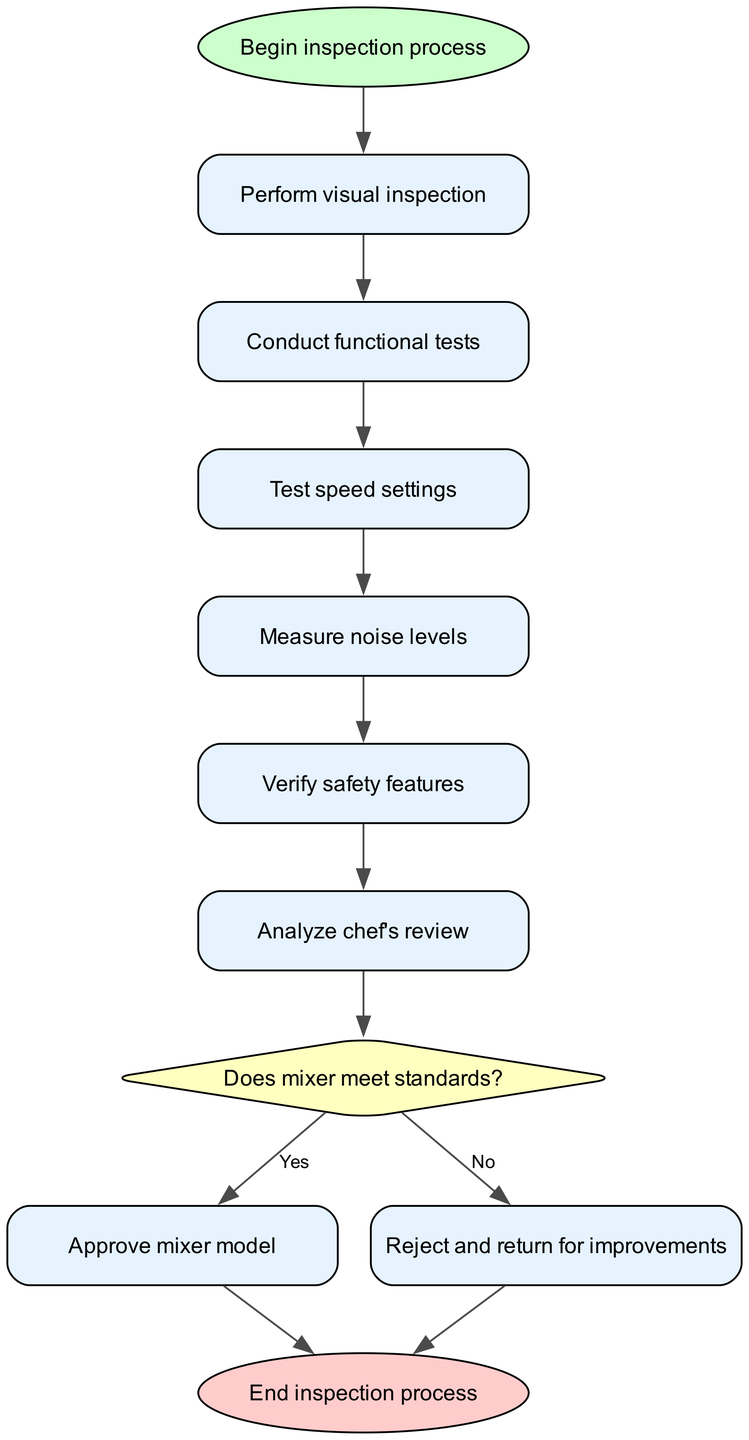What is the first step in the inspection process? The diagram shows that the first node is labeled "Begin inspection process," indicating it is the starting point of the flowchart.
Answer: Begin inspection process How many functional tests are conducted after visual inspection? From the diagram, the flow goes from "Perform visual inspection" to "Conduct functional tests," which indicates that one functional test is conducted after the visual inspection.
Answer: One What is the last node before the inspection process ends? The flowchart leads to "Approve mixer model" or "Reject and return for improvements" before it concludes at "End inspection process." Thus, the last node can be either of the two based on the decision.
Answer: Approve mixer model or Reject and return for improvements What safety feature verification occurs after testing noise levels? The diagram clearly shows that after "Measure noise levels," the next step is "Verify safety features," indicating that safety feature verification occurs immediately afterward.
Answer: Verify safety features What happens if the mixer does not meet standards? According to the flowchart, if the decision is "No," then the flow leads to "Reject and return for improvements," indicating that the mixer will be rejected for necessary adjustments.
Answer: Reject and return for improvements How are chef's reviews analyzed in the quality control process? The flowchart indicates that after verifying safety features, the next step is "Analyze chef's review," which confirms that chef's reviews are analyzed following the safety check.
Answer: Analyze chef's review In total, how many nodes are in this diagram? By counting all the labeled nodes in the diagram, there are ten nodes representing different steps in the quality control inspection process.
Answer: Ten What shape represents the decision-making point in the process? The diagram uses a diamond shape to represent the decision-making point labeled "Does mixer meet standards?" This shape is a standard representation for decision nodes in flowcharts.
Answer: Diamond What occurs if the mixer meets the quality standards? If the mixer meets the standards, as indicated by a "Yes" from the decision node, the process continues to the "Approve mixer model" node.
Answer: Approve mixer model 